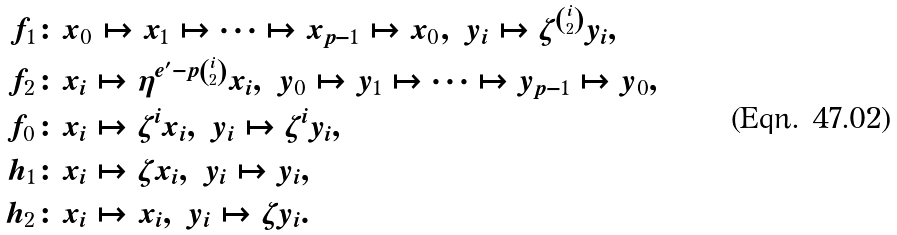Convert formula to latex. <formula><loc_0><loc_0><loc_500><loc_500>f _ { 1 } & \colon x _ { 0 } \mapsto x _ { 1 } \mapsto \cdots \mapsto x _ { p - 1 } \mapsto x _ { 0 } , \ y _ { i } \mapsto \zeta ^ { \binom { i } { 2 } } y _ { i } , \\ f _ { 2 } & \colon x _ { i } \mapsto \eta ^ { e ^ { \prime } - p \binom { i } { 2 } } x _ { i } , \ y _ { 0 } \mapsto y _ { 1 } \mapsto \cdots \mapsto y _ { p - 1 } \mapsto y _ { 0 } , \\ f _ { 0 } & \colon x _ { i } \mapsto \zeta ^ { i } x _ { i } , \ y _ { i } \mapsto \zeta ^ { i } y _ { i } , \\ h _ { 1 } & \colon x _ { i } \mapsto \zeta x _ { i } , \ y _ { i } \mapsto y _ { i } , \\ h _ { 2 } & \colon x _ { i } \mapsto x _ { i } , \ y _ { i } \mapsto \zeta y _ { i } .</formula> 